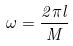Convert formula to latex. <formula><loc_0><loc_0><loc_500><loc_500>\omega = \frac { 2 \pi l } { M }</formula> 